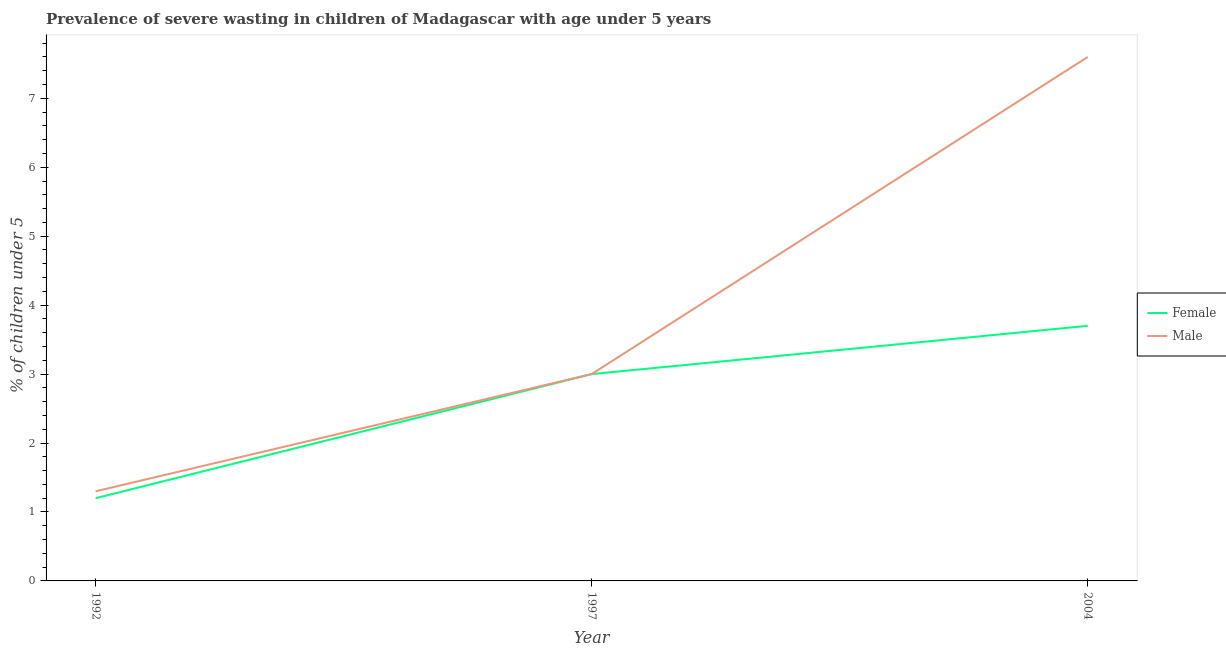How many different coloured lines are there?
Offer a terse response. 2. Does the line corresponding to percentage of undernourished female children intersect with the line corresponding to percentage of undernourished male children?
Offer a terse response. Yes. What is the percentage of undernourished female children in 1997?
Keep it short and to the point. 3. Across all years, what is the maximum percentage of undernourished male children?
Give a very brief answer. 7.6. Across all years, what is the minimum percentage of undernourished male children?
Your answer should be very brief. 1.3. In which year was the percentage of undernourished female children maximum?
Your answer should be very brief. 2004. In which year was the percentage of undernourished female children minimum?
Ensure brevity in your answer.  1992. What is the total percentage of undernourished male children in the graph?
Your response must be concise. 11.9. What is the difference between the percentage of undernourished male children in 2004 and the percentage of undernourished female children in 1997?
Keep it short and to the point. 4.6. What is the average percentage of undernourished male children per year?
Make the answer very short. 3.97. In the year 2004, what is the difference between the percentage of undernourished male children and percentage of undernourished female children?
Your response must be concise. 3.9. What is the ratio of the percentage of undernourished male children in 1992 to that in 1997?
Keep it short and to the point. 0.43. Is the difference between the percentage of undernourished male children in 1992 and 1997 greater than the difference between the percentage of undernourished female children in 1992 and 1997?
Ensure brevity in your answer.  Yes. What is the difference between the highest and the second highest percentage of undernourished female children?
Your response must be concise. 0.7. Is the sum of the percentage of undernourished female children in 1992 and 2004 greater than the maximum percentage of undernourished male children across all years?
Ensure brevity in your answer.  No. Is the percentage of undernourished male children strictly less than the percentage of undernourished female children over the years?
Keep it short and to the point. No. Are the values on the major ticks of Y-axis written in scientific E-notation?
Provide a short and direct response. No. Does the graph contain any zero values?
Provide a succinct answer. No. Does the graph contain grids?
Offer a very short reply. No. How are the legend labels stacked?
Make the answer very short. Vertical. What is the title of the graph?
Provide a short and direct response. Prevalence of severe wasting in children of Madagascar with age under 5 years. Does "From World Bank" appear as one of the legend labels in the graph?
Provide a succinct answer. No. What is the label or title of the X-axis?
Your response must be concise. Year. What is the label or title of the Y-axis?
Offer a terse response.  % of children under 5. What is the  % of children under 5 of Female in 1992?
Keep it short and to the point. 1.2. What is the  % of children under 5 in Male in 1992?
Your response must be concise. 1.3. What is the  % of children under 5 of Female in 1997?
Offer a terse response. 3. What is the  % of children under 5 of Female in 2004?
Keep it short and to the point. 3.7. What is the  % of children under 5 of Male in 2004?
Ensure brevity in your answer.  7.6. Across all years, what is the maximum  % of children under 5 of Female?
Give a very brief answer. 3.7. Across all years, what is the maximum  % of children under 5 in Male?
Ensure brevity in your answer.  7.6. Across all years, what is the minimum  % of children under 5 in Female?
Your response must be concise. 1.2. Across all years, what is the minimum  % of children under 5 of Male?
Give a very brief answer. 1.3. What is the difference between the  % of children under 5 of Female in 1992 and that in 2004?
Your answer should be compact. -2.5. What is the difference between the  % of children under 5 of Female in 1997 and that in 2004?
Offer a terse response. -0.7. What is the difference between the  % of children under 5 of Female in 1992 and the  % of children under 5 of Male in 1997?
Give a very brief answer. -1.8. What is the average  % of children under 5 of Female per year?
Keep it short and to the point. 2.63. What is the average  % of children under 5 in Male per year?
Provide a succinct answer. 3.97. In the year 1997, what is the difference between the  % of children under 5 in Female and  % of children under 5 in Male?
Provide a short and direct response. 0. What is the ratio of the  % of children under 5 of Male in 1992 to that in 1997?
Provide a short and direct response. 0.43. What is the ratio of the  % of children under 5 of Female in 1992 to that in 2004?
Ensure brevity in your answer.  0.32. What is the ratio of the  % of children under 5 in Male in 1992 to that in 2004?
Offer a very short reply. 0.17. What is the ratio of the  % of children under 5 in Female in 1997 to that in 2004?
Offer a terse response. 0.81. What is the ratio of the  % of children under 5 of Male in 1997 to that in 2004?
Provide a short and direct response. 0.39. What is the difference between the highest and the lowest  % of children under 5 in Male?
Provide a succinct answer. 6.3. 